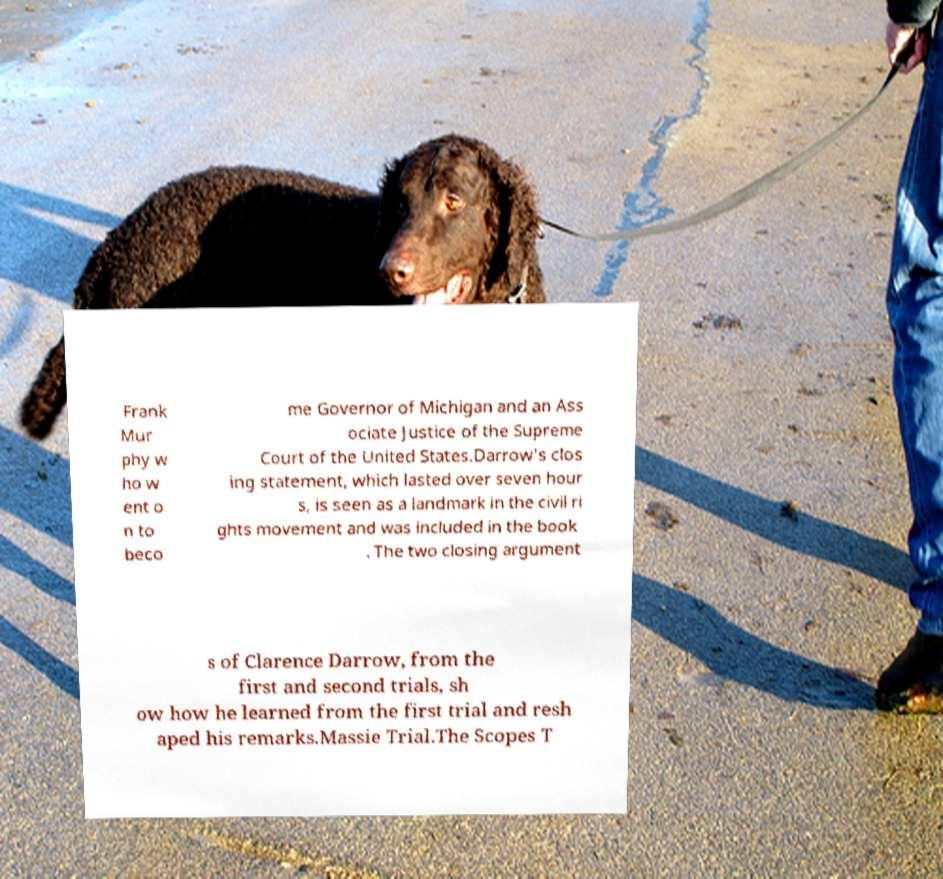Please read and relay the text visible in this image. What does it say? Frank Mur phy w ho w ent o n to beco me Governor of Michigan and an Ass ociate Justice of the Supreme Court of the United States.Darrow's clos ing statement, which lasted over seven hour s, is seen as a landmark in the civil ri ghts movement and was included in the book . The two closing argument s of Clarence Darrow, from the first and second trials, sh ow how he learned from the first trial and resh aped his remarks.Massie Trial.The Scopes T 